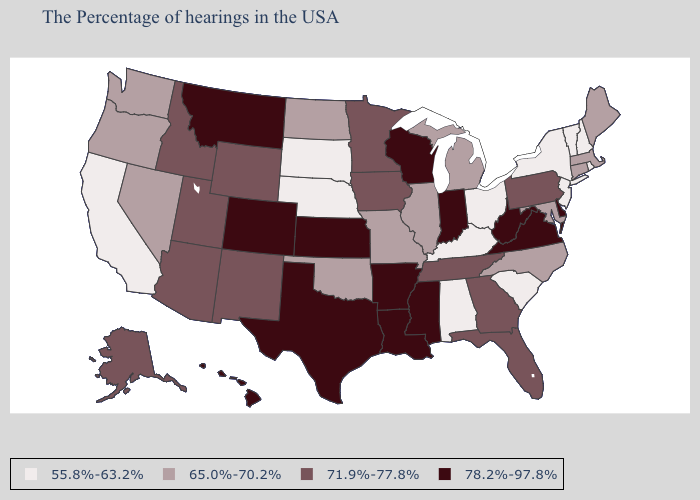What is the value of Iowa?
Quick response, please. 71.9%-77.8%. Among the states that border Indiana , which have the lowest value?
Short answer required. Ohio, Kentucky. Among the states that border New Hampshire , which have the highest value?
Keep it brief. Maine, Massachusetts. Name the states that have a value in the range 78.2%-97.8%?
Short answer required. Delaware, Virginia, West Virginia, Indiana, Wisconsin, Mississippi, Louisiana, Arkansas, Kansas, Texas, Colorado, Montana, Hawaii. What is the value of Maine?
Write a very short answer. 65.0%-70.2%. What is the value of Hawaii?
Short answer required. 78.2%-97.8%. What is the lowest value in states that border Kentucky?
Be succinct. 55.8%-63.2%. Name the states that have a value in the range 78.2%-97.8%?
Short answer required. Delaware, Virginia, West Virginia, Indiana, Wisconsin, Mississippi, Louisiana, Arkansas, Kansas, Texas, Colorado, Montana, Hawaii. Name the states that have a value in the range 55.8%-63.2%?
Keep it brief. Rhode Island, New Hampshire, Vermont, New York, New Jersey, South Carolina, Ohio, Kentucky, Alabama, Nebraska, South Dakota, California. Which states have the highest value in the USA?
Answer briefly. Delaware, Virginia, West Virginia, Indiana, Wisconsin, Mississippi, Louisiana, Arkansas, Kansas, Texas, Colorado, Montana, Hawaii. Which states have the lowest value in the West?
Concise answer only. California. What is the lowest value in the MidWest?
Keep it brief. 55.8%-63.2%. How many symbols are there in the legend?
Give a very brief answer. 4. Name the states that have a value in the range 71.9%-77.8%?
Be succinct. Pennsylvania, Florida, Georgia, Tennessee, Minnesota, Iowa, Wyoming, New Mexico, Utah, Arizona, Idaho, Alaska. 